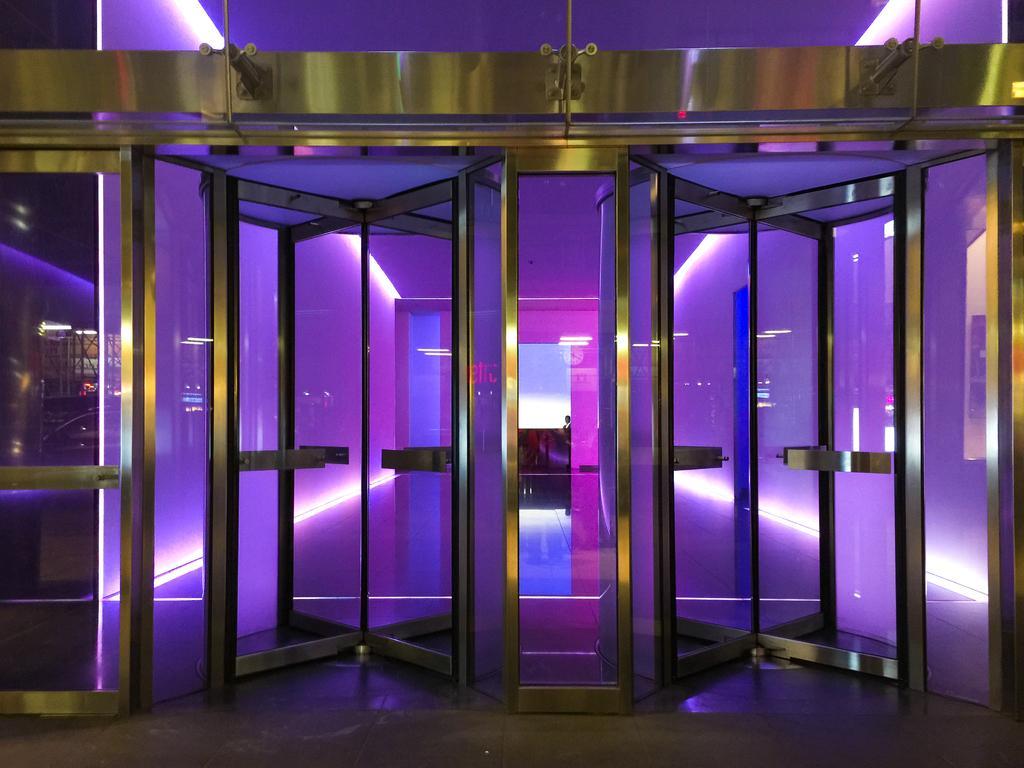Could you give a brief overview of what you see in this image? In this picture I can see there are two doors and they have glass, there is a purple light attached and there is a man standing in the backdrop. 